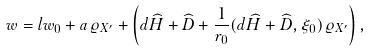<formula> <loc_0><loc_0><loc_500><loc_500>w = l w _ { 0 } + a \varrho _ { X ^ { \prime } } + \left ( d \widehat { H } + \widehat { D } + \frac { 1 } { r _ { 0 } } ( d \widehat { H } + \widehat { D } , \xi _ { 0 } ) \varrho _ { X ^ { \prime } } \right ) ,</formula> 